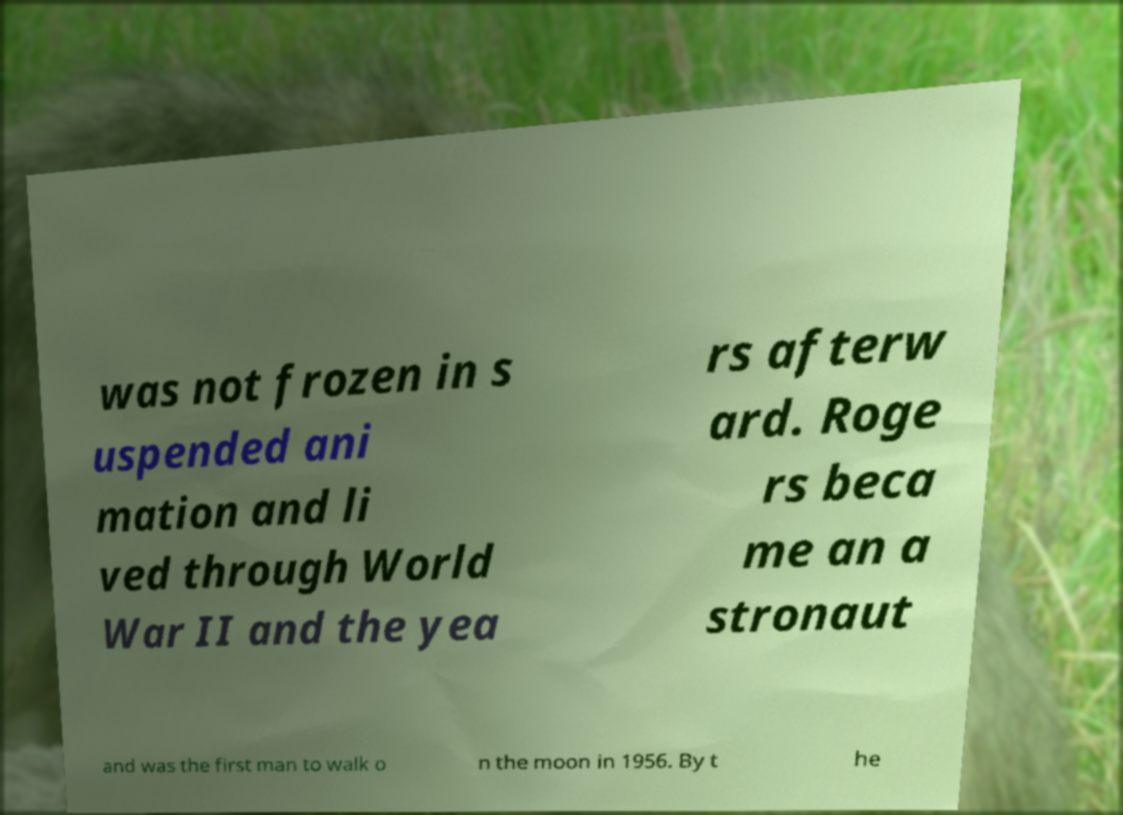Can you read and provide the text displayed in the image?This photo seems to have some interesting text. Can you extract and type it out for me? was not frozen in s uspended ani mation and li ved through World War II and the yea rs afterw ard. Roge rs beca me an a stronaut and was the first man to walk o n the moon in 1956. By t he 